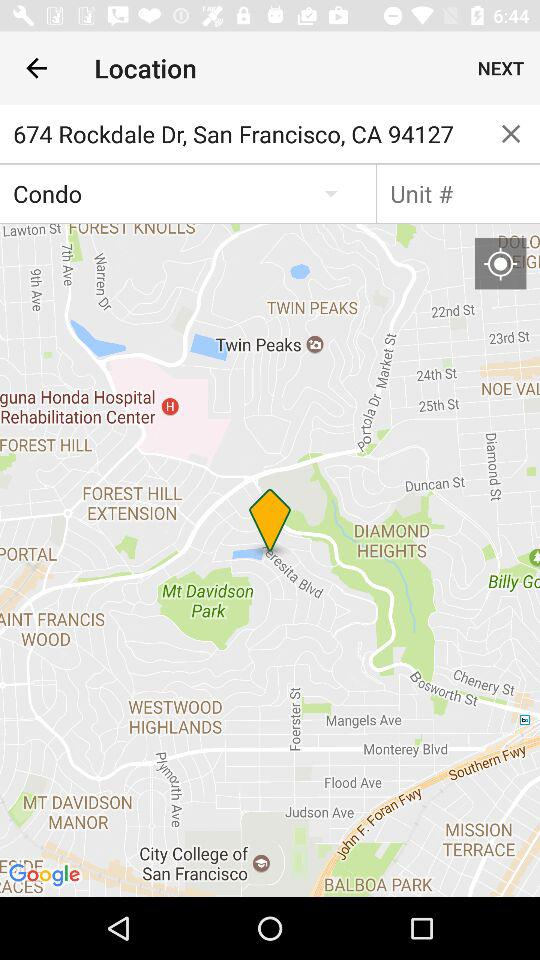What is the location? The location is 674 Rockdale Dr, San Francisco, CA 94127. 